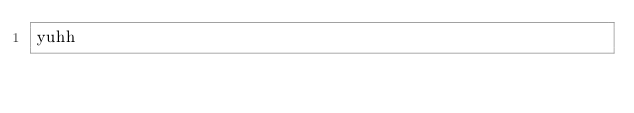Convert code to text. <code><loc_0><loc_0><loc_500><loc_500><_C_>yuhh</code> 